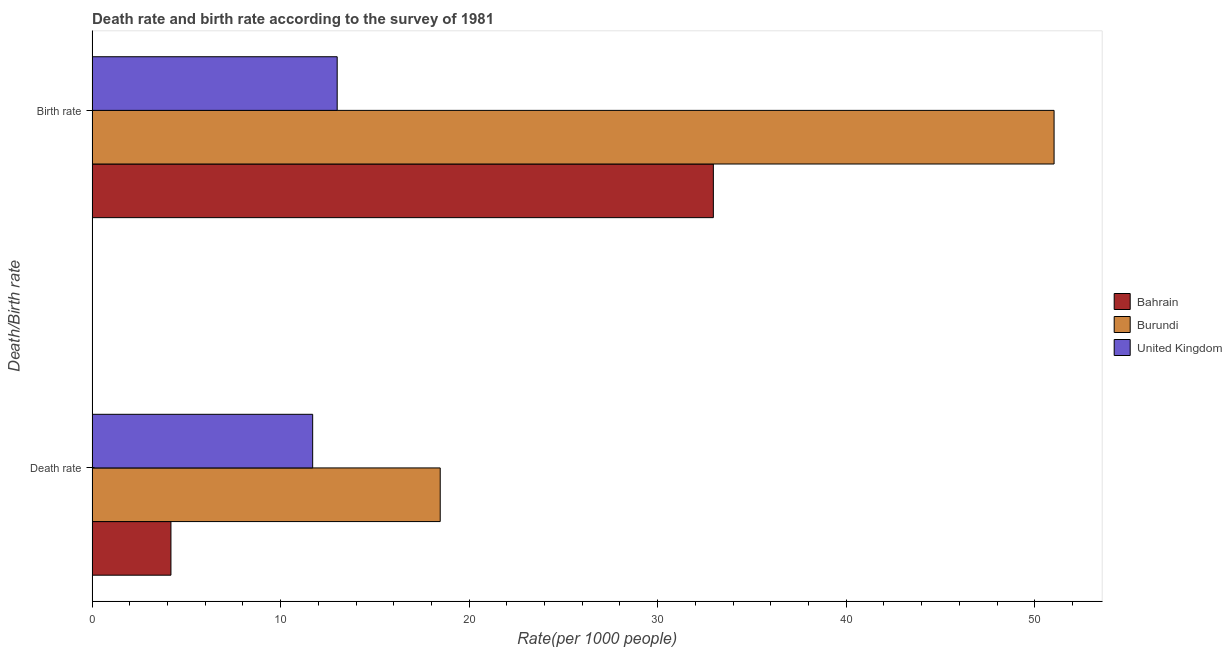Are the number of bars per tick equal to the number of legend labels?
Offer a terse response. Yes. Are the number of bars on each tick of the Y-axis equal?
Offer a very short reply. Yes. How many bars are there on the 2nd tick from the top?
Give a very brief answer. 3. What is the label of the 1st group of bars from the top?
Provide a succinct answer. Birth rate. Across all countries, what is the maximum death rate?
Your answer should be compact. 18.46. In which country was the birth rate maximum?
Your answer should be very brief. Burundi. In which country was the death rate minimum?
Provide a succinct answer. Bahrain. What is the total death rate in the graph?
Offer a very short reply. 34.35. What is the difference between the death rate in Bahrain and that in Burundi?
Keep it short and to the point. -14.28. What is the difference between the death rate in Bahrain and the birth rate in Burundi?
Provide a succinct answer. -46.84. What is the average death rate per country?
Your answer should be very brief. 11.45. What is the difference between the death rate and birth rate in Bahrain?
Offer a terse response. -28.77. In how many countries, is the death rate greater than 40 ?
Provide a succinct answer. 0. What is the ratio of the death rate in United Kingdom to that in Bahrain?
Ensure brevity in your answer.  2.8. Is the birth rate in United Kingdom less than that in Burundi?
Offer a very short reply. Yes. What does the 2nd bar from the top in Death rate represents?
Your response must be concise. Burundi. What does the 2nd bar from the bottom in Death rate represents?
Your answer should be compact. Burundi. Are all the bars in the graph horizontal?
Your answer should be very brief. Yes. How many countries are there in the graph?
Provide a short and direct response. 3. Are the values on the major ticks of X-axis written in scientific E-notation?
Your answer should be very brief. No. Does the graph contain grids?
Make the answer very short. No. Where does the legend appear in the graph?
Your response must be concise. Center right. How many legend labels are there?
Your answer should be very brief. 3. How are the legend labels stacked?
Give a very brief answer. Vertical. What is the title of the graph?
Your response must be concise. Death rate and birth rate according to the survey of 1981. Does "San Marino" appear as one of the legend labels in the graph?
Provide a succinct answer. No. What is the label or title of the X-axis?
Make the answer very short. Rate(per 1000 people). What is the label or title of the Y-axis?
Your answer should be compact. Death/Birth rate. What is the Rate(per 1000 people) of Bahrain in Death rate?
Make the answer very short. 4.18. What is the Rate(per 1000 people) in Burundi in Death rate?
Your answer should be compact. 18.46. What is the Rate(per 1000 people) in United Kingdom in Death rate?
Offer a very short reply. 11.7. What is the Rate(per 1000 people) in Bahrain in Birth rate?
Make the answer very short. 32.95. What is the Rate(per 1000 people) in Burundi in Birth rate?
Provide a short and direct response. 51.03. What is the Rate(per 1000 people) in United Kingdom in Birth rate?
Make the answer very short. 13. Across all Death/Birth rate, what is the maximum Rate(per 1000 people) of Bahrain?
Your answer should be very brief. 32.95. Across all Death/Birth rate, what is the maximum Rate(per 1000 people) of Burundi?
Ensure brevity in your answer.  51.03. Across all Death/Birth rate, what is the maximum Rate(per 1000 people) in United Kingdom?
Keep it short and to the point. 13. Across all Death/Birth rate, what is the minimum Rate(per 1000 people) of Bahrain?
Give a very brief answer. 4.18. Across all Death/Birth rate, what is the minimum Rate(per 1000 people) in Burundi?
Your answer should be compact. 18.46. What is the total Rate(per 1000 people) in Bahrain in the graph?
Offer a terse response. 37.13. What is the total Rate(per 1000 people) of Burundi in the graph?
Your response must be concise. 69.49. What is the total Rate(per 1000 people) in United Kingdom in the graph?
Provide a succinct answer. 24.7. What is the difference between the Rate(per 1000 people) in Bahrain in Death rate and that in Birth rate?
Offer a very short reply. -28.77. What is the difference between the Rate(per 1000 people) of Burundi in Death rate and that in Birth rate?
Provide a succinct answer. -32.56. What is the difference between the Rate(per 1000 people) in United Kingdom in Death rate and that in Birth rate?
Offer a very short reply. -1.3. What is the difference between the Rate(per 1000 people) of Bahrain in Death rate and the Rate(per 1000 people) of Burundi in Birth rate?
Provide a short and direct response. -46.84. What is the difference between the Rate(per 1000 people) of Bahrain in Death rate and the Rate(per 1000 people) of United Kingdom in Birth rate?
Your answer should be compact. -8.82. What is the difference between the Rate(per 1000 people) in Burundi in Death rate and the Rate(per 1000 people) in United Kingdom in Birth rate?
Give a very brief answer. 5.46. What is the average Rate(per 1000 people) of Bahrain per Death/Birth rate?
Ensure brevity in your answer.  18.57. What is the average Rate(per 1000 people) in Burundi per Death/Birth rate?
Keep it short and to the point. 34.75. What is the average Rate(per 1000 people) of United Kingdom per Death/Birth rate?
Provide a succinct answer. 12.35. What is the difference between the Rate(per 1000 people) of Bahrain and Rate(per 1000 people) of Burundi in Death rate?
Ensure brevity in your answer.  -14.28. What is the difference between the Rate(per 1000 people) of Bahrain and Rate(per 1000 people) of United Kingdom in Death rate?
Make the answer very short. -7.52. What is the difference between the Rate(per 1000 people) of Burundi and Rate(per 1000 people) of United Kingdom in Death rate?
Ensure brevity in your answer.  6.76. What is the difference between the Rate(per 1000 people) of Bahrain and Rate(per 1000 people) of Burundi in Birth rate?
Provide a succinct answer. -18.07. What is the difference between the Rate(per 1000 people) in Bahrain and Rate(per 1000 people) in United Kingdom in Birth rate?
Offer a terse response. 19.95. What is the difference between the Rate(per 1000 people) of Burundi and Rate(per 1000 people) of United Kingdom in Birth rate?
Your answer should be very brief. 38.03. What is the ratio of the Rate(per 1000 people) of Bahrain in Death rate to that in Birth rate?
Your answer should be very brief. 0.13. What is the ratio of the Rate(per 1000 people) in Burundi in Death rate to that in Birth rate?
Provide a succinct answer. 0.36. What is the ratio of the Rate(per 1000 people) in United Kingdom in Death rate to that in Birth rate?
Provide a short and direct response. 0.9. What is the difference between the highest and the second highest Rate(per 1000 people) of Bahrain?
Ensure brevity in your answer.  28.77. What is the difference between the highest and the second highest Rate(per 1000 people) of Burundi?
Make the answer very short. 32.56. What is the difference between the highest and the lowest Rate(per 1000 people) of Bahrain?
Your answer should be very brief. 28.77. What is the difference between the highest and the lowest Rate(per 1000 people) of Burundi?
Offer a terse response. 32.56. What is the difference between the highest and the lowest Rate(per 1000 people) in United Kingdom?
Provide a short and direct response. 1.3. 